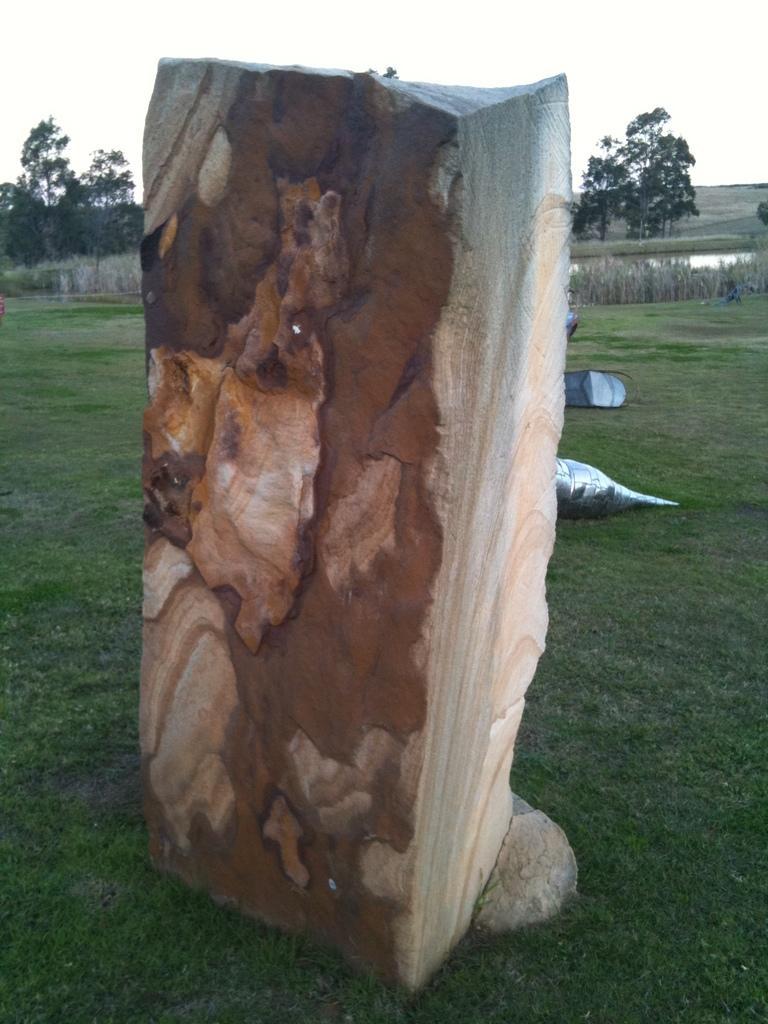In one or two sentences, can you explain what this image depicts? In this picture I can see a wooden log, and there is grass, plants, trees, water, and in the background there is sky. 